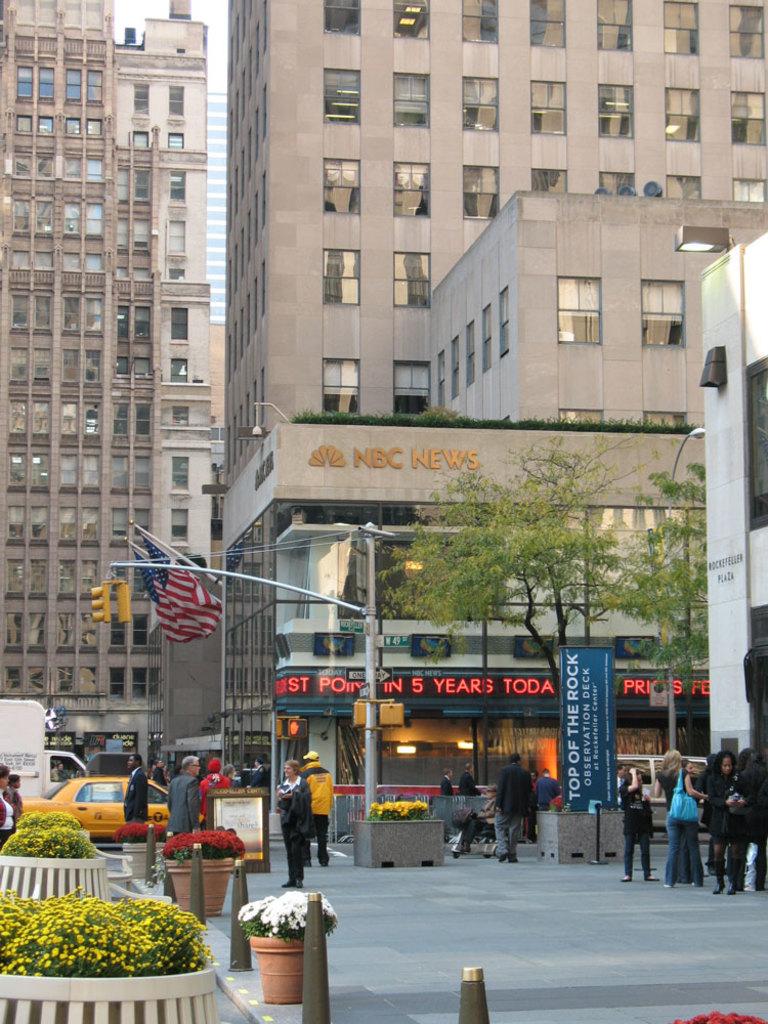What is the name of the observation deck?
Your response must be concise. Top of the rock. 